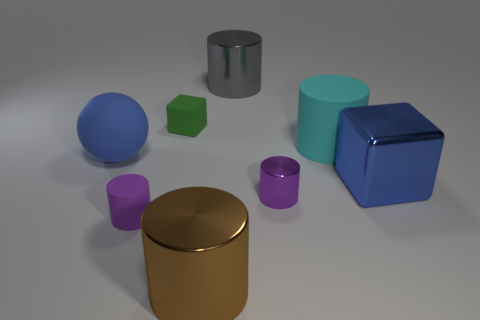Subtract all gray cylinders. How many cylinders are left? 4 Subtract all big matte cylinders. How many cylinders are left? 4 Subtract all red cylinders. Subtract all yellow balls. How many cylinders are left? 5 Add 1 large brown matte spheres. How many objects exist? 9 Subtract all cubes. How many objects are left? 6 Add 7 balls. How many balls exist? 8 Subtract 0 red balls. How many objects are left? 8 Subtract all small cubes. Subtract all purple matte cylinders. How many objects are left? 6 Add 7 spheres. How many spheres are left? 8 